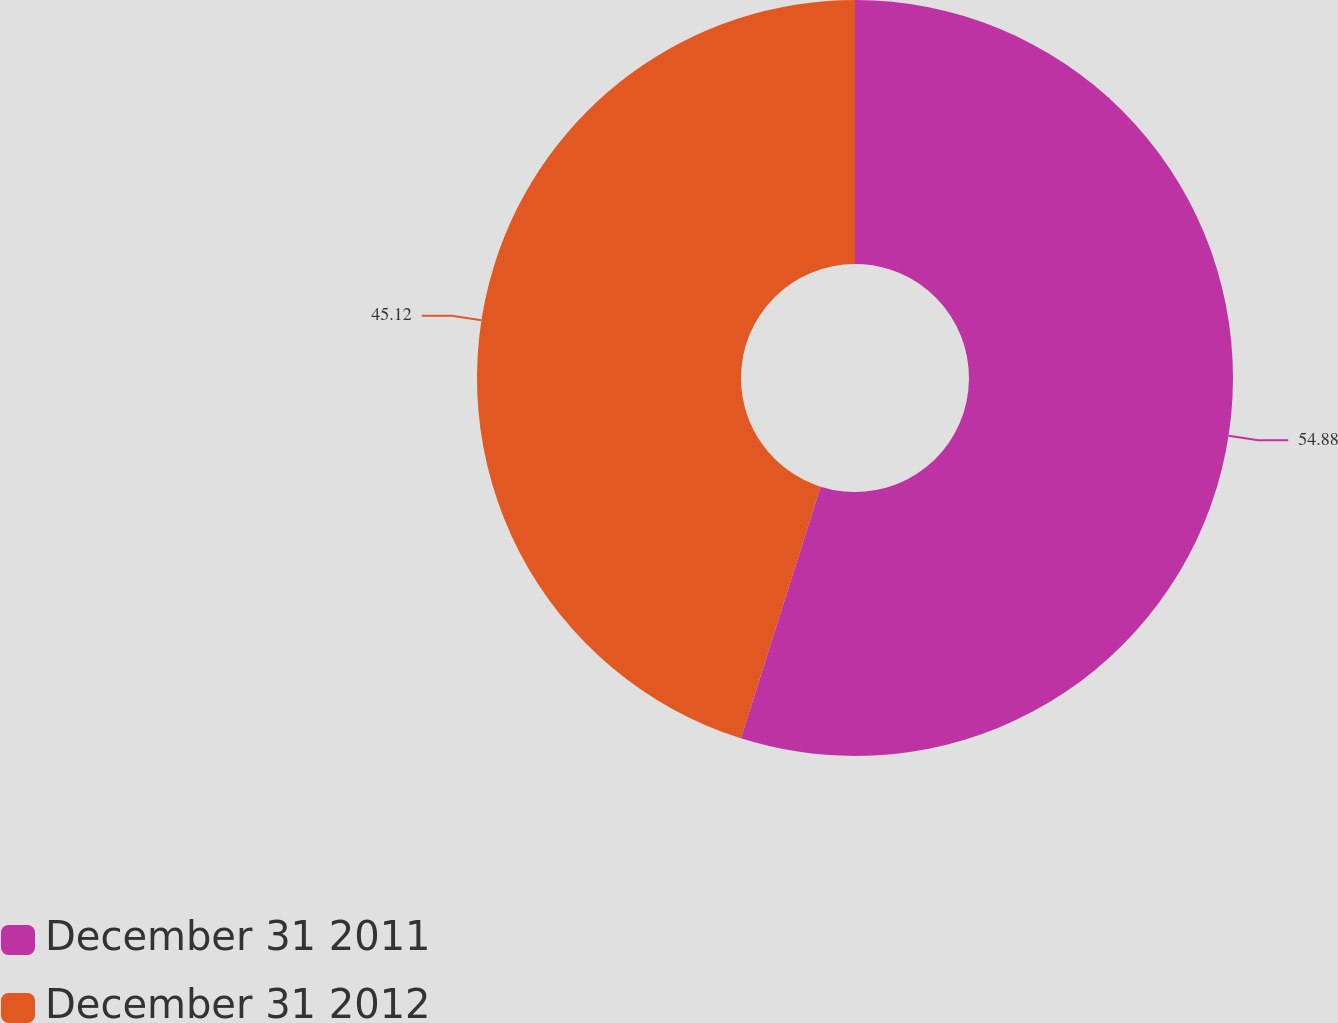Convert chart. <chart><loc_0><loc_0><loc_500><loc_500><pie_chart><fcel>December 31 2011<fcel>December 31 2012<nl><fcel>54.88%<fcel>45.12%<nl></chart> 